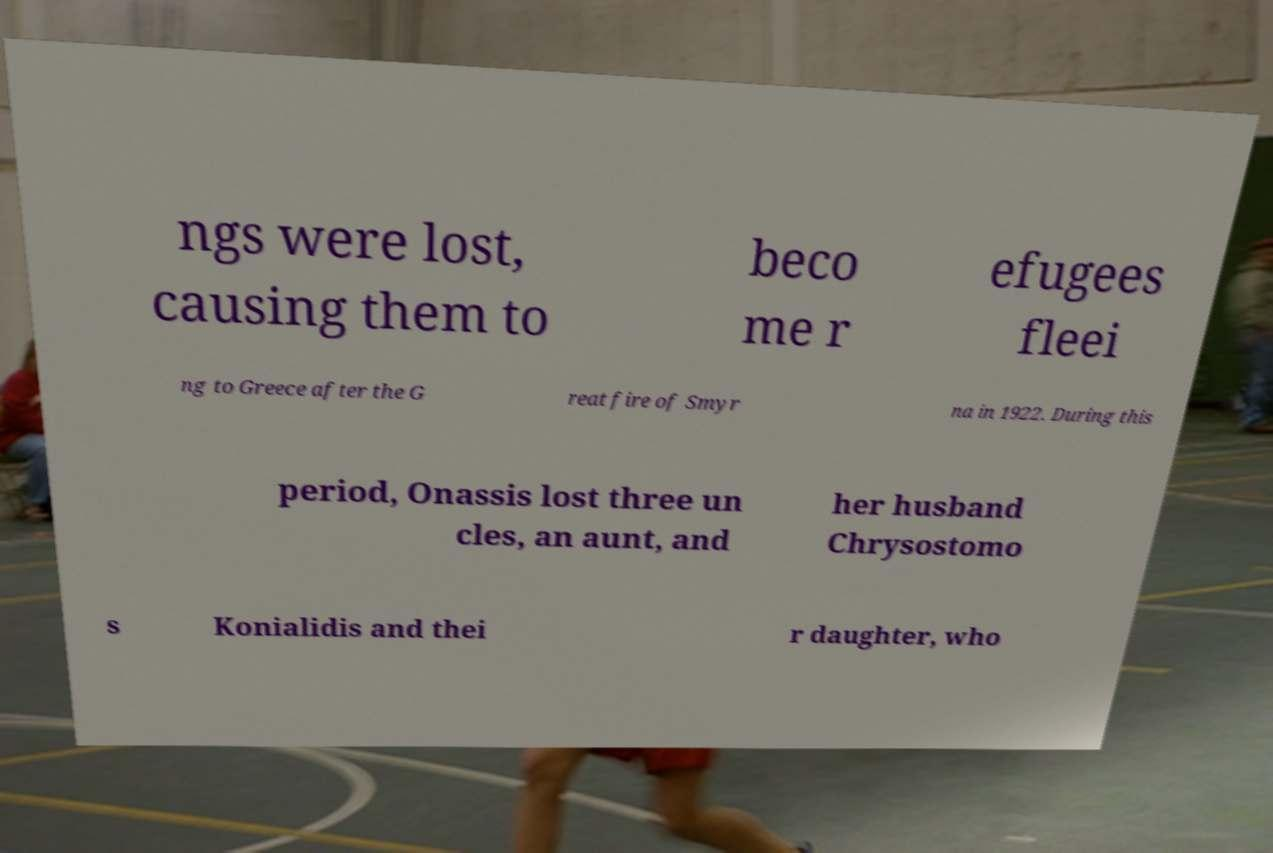Please read and relay the text visible in this image. What does it say? ngs were lost, causing them to beco me r efugees fleei ng to Greece after the G reat fire of Smyr na in 1922. During this period, Onassis lost three un cles, an aunt, and her husband Chrysostomo s Konialidis and thei r daughter, who 